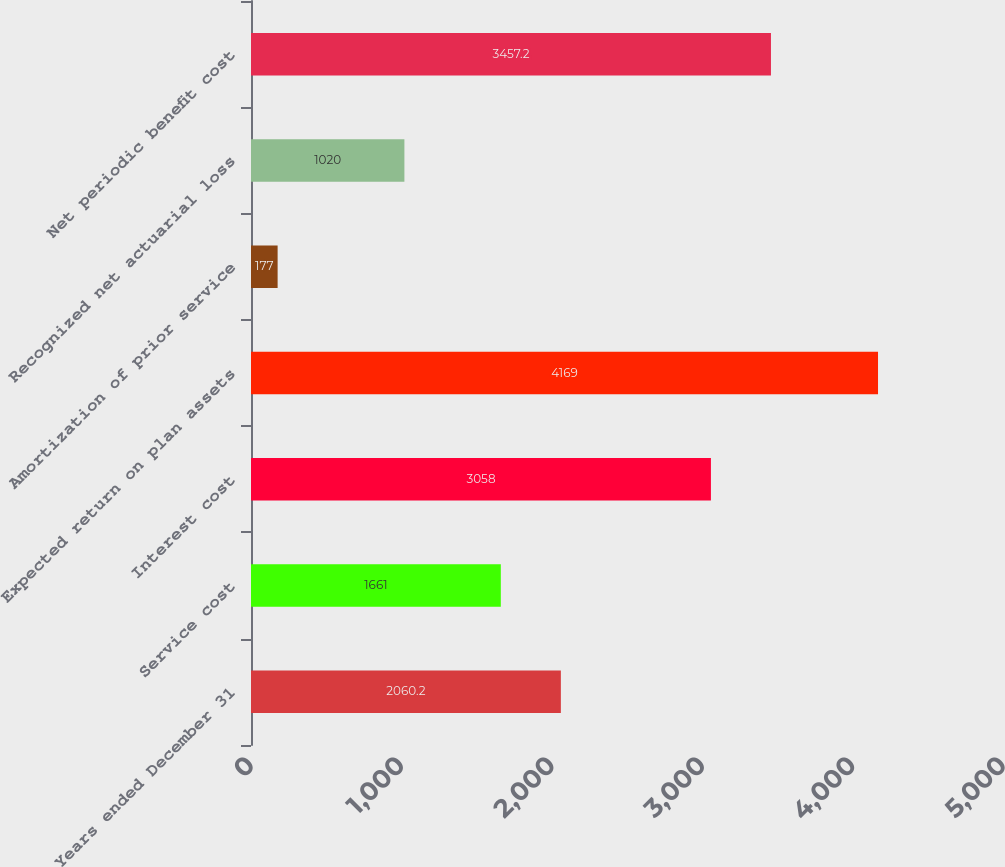<chart> <loc_0><loc_0><loc_500><loc_500><bar_chart><fcel>Years ended December 31<fcel>Service cost<fcel>Interest cost<fcel>Expected return on plan assets<fcel>Amortization of prior service<fcel>Recognized net actuarial loss<fcel>Net periodic benefit cost<nl><fcel>2060.2<fcel>1661<fcel>3058<fcel>4169<fcel>177<fcel>1020<fcel>3457.2<nl></chart> 